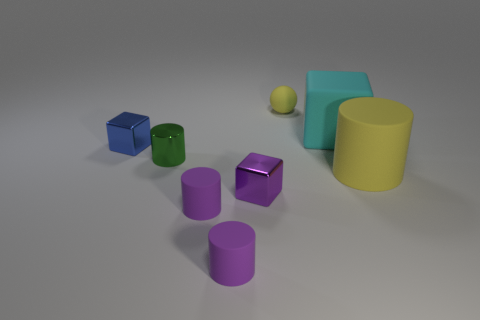Is the shape of the large yellow object the same as the cyan thing?
Your response must be concise. No. Are there any other large things of the same shape as the blue object?
Offer a very short reply. Yes. What shape is the yellow rubber object that is in front of the small green cylinder that is to the left of the big yellow cylinder?
Provide a short and direct response. Cylinder. There is a matte cylinder on the right side of the tiny sphere; what color is it?
Offer a very short reply. Yellow. There is a green cylinder that is made of the same material as the blue cube; what is its size?
Keep it short and to the point. Small. What size is the matte object that is the same shape as the tiny purple metal object?
Give a very brief answer. Large. Is there a big gray ball?
Provide a short and direct response. No. How many things are either small objects behind the large block or objects?
Offer a very short reply. 8. There is a yellow object that is the same size as the cyan matte thing; what material is it?
Give a very brief answer. Rubber. There is a tiny metallic block that is left of the purple shiny cube in front of the sphere; what is its color?
Offer a terse response. Blue. 